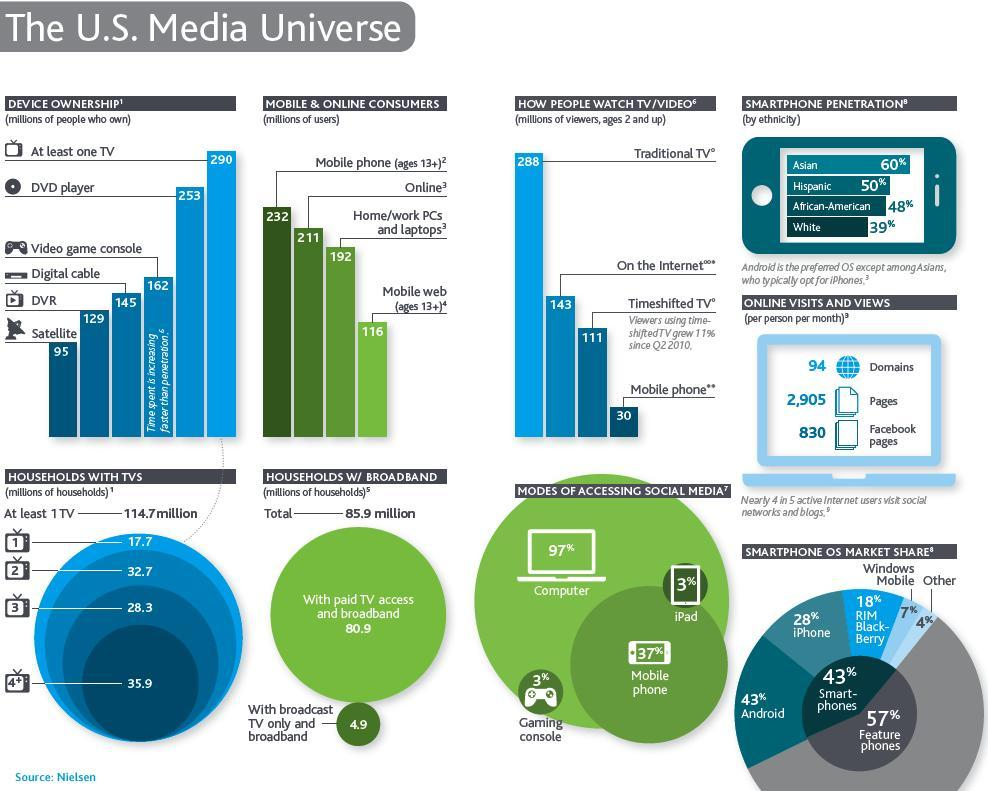what is the market share of iphone and android
Answer the question with a short phrase. 71 what is the most preferred mode of accessing social media computer what is the count of online users 211 what is the total of online visits and views to domains and pages 2999 what is the age group considered for mobile web users 13+ African American smartphone penetration is greater than which ethinicity White how many households have more than 3 tv 35.9 how many households have less than 3 tv 50.4 which ethinicity opts for Iphone more Asians 